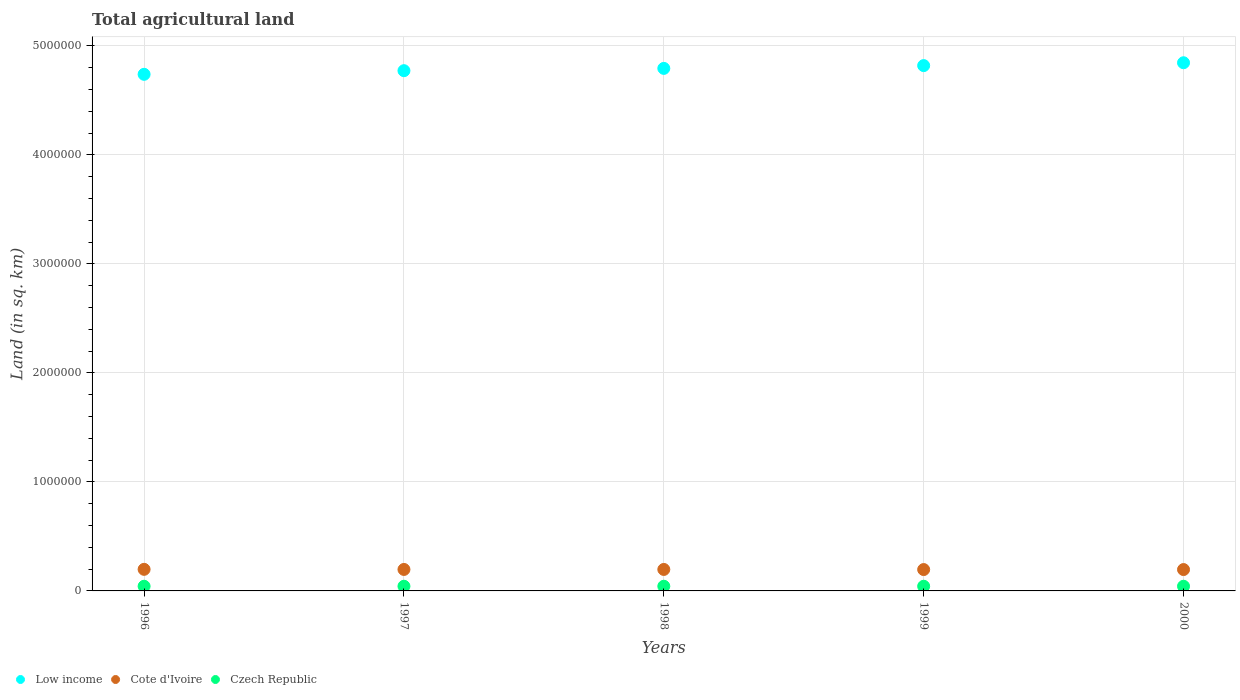How many different coloured dotlines are there?
Your answer should be compact. 3. What is the total agricultural land in Cote d'Ivoire in 1998?
Offer a very short reply. 1.97e+05. Across all years, what is the maximum total agricultural land in Cote d'Ivoire?
Keep it short and to the point. 1.98e+05. Across all years, what is the minimum total agricultural land in Low income?
Ensure brevity in your answer.  4.74e+06. In which year was the total agricultural land in Cote d'Ivoire maximum?
Your answer should be very brief. 1996. In which year was the total agricultural land in Low income minimum?
Your response must be concise. 1996. What is the total total agricultural land in Czech Republic in the graph?
Keep it short and to the point. 2.14e+05. What is the difference between the total agricultural land in Low income in 1999 and the total agricultural land in Czech Republic in 1996?
Your response must be concise. 4.78e+06. What is the average total agricultural land in Low income per year?
Provide a short and direct response. 4.79e+06. In the year 2000, what is the difference between the total agricultural land in Cote d'Ivoire and total agricultural land in Czech Republic?
Make the answer very short. 1.53e+05. In how many years, is the total agricultural land in Czech Republic greater than 4200000 sq.km?
Keep it short and to the point. 0. What is the ratio of the total agricultural land in Cote d'Ivoire in 1997 to that in 2000?
Offer a very short reply. 1.01. Is the difference between the total agricultural land in Cote d'Ivoire in 1998 and 1999 greater than the difference between the total agricultural land in Czech Republic in 1998 and 1999?
Give a very brief answer. Yes. What is the difference between the highest and the lowest total agricultural land in Czech Republic?
Your answer should be very brief. 40. Is the sum of the total agricultural land in Low income in 1999 and 2000 greater than the maximum total agricultural land in Czech Republic across all years?
Keep it short and to the point. Yes. Does the total agricultural land in Low income monotonically increase over the years?
Ensure brevity in your answer.  Yes. Is the total agricultural land in Czech Republic strictly greater than the total agricultural land in Low income over the years?
Make the answer very short. No. Is the total agricultural land in Low income strictly less than the total agricultural land in Cote d'Ivoire over the years?
Give a very brief answer. No. How many years are there in the graph?
Give a very brief answer. 5. What is the difference between two consecutive major ticks on the Y-axis?
Offer a very short reply. 1.00e+06. Does the graph contain grids?
Your answer should be compact. Yes. Where does the legend appear in the graph?
Keep it short and to the point. Bottom left. How many legend labels are there?
Offer a terse response. 3. What is the title of the graph?
Your answer should be compact. Total agricultural land. Does "Ecuador" appear as one of the legend labels in the graph?
Give a very brief answer. No. What is the label or title of the Y-axis?
Your answer should be very brief. Land (in sq. km). What is the Land (in sq. km) of Low income in 1996?
Offer a very short reply. 4.74e+06. What is the Land (in sq. km) of Cote d'Ivoire in 1996?
Make the answer very short. 1.98e+05. What is the Land (in sq. km) in Czech Republic in 1996?
Provide a short and direct response. 4.28e+04. What is the Land (in sq. km) of Low income in 1997?
Provide a short and direct response. 4.77e+06. What is the Land (in sq. km) in Cote d'Ivoire in 1997?
Provide a succinct answer. 1.97e+05. What is the Land (in sq. km) in Czech Republic in 1997?
Your answer should be compact. 4.28e+04. What is the Land (in sq. km) in Low income in 1998?
Provide a succinct answer. 4.79e+06. What is the Land (in sq. km) in Cote d'Ivoire in 1998?
Your response must be concise. 1.97e+05. What is the Land (in sq. km) of Czech Republic in 1998?
Offer a terse response. 4.28e+04. What is the Land (in sq. km) of Low income in 1999?
Your answer should be very brief. 4.82e+06. What is the Land (in sq. km) in Cote d'Ivoire in 1999?
Your answer should be very brief. 1.96e+05. What is the Land (in sq. km) of Czech Republic in 1999?
Provide a succinct answer. 4.28e+04. What is the Land (in sq. km) in Low income in 2000?
Provide a short and direct response. 4.85e+06. What is the Land (in sq. km) in Cote d'Ivoire in 2000?
Your response must be concise. 1.96e+05. What is the Land (in sq. km) of Czech Republic in 2000?
Provide a short and direct response. 4.28e+04. Across all years, what is the maximum Land (in sq. km) in Low income?
Make the answer very short. 4.85e+06. Across all years, what is the maximum Land (in sq. km) of Cote d'Ivoire?
Keep it short and to the point. 1.98e+05. Across all years, what is the maximum Land (in sq. km) of Czech Republic?
Provide a short and direct response. 4.28e+04. Across all years, what is the minimum Land (in sq. km) in Low income?
Give a very brief answer. 4.74e+06. Across all years, what is the minimum Land (in sq. km) in Cote d'Ivoire?
Ensure brevity in your answer.  1.96e+05. Across all years, what is the minimum Land (in sq. km) of Czech Republic?
Ensure brevity in your answer.  4.28e+04. What is the total Land (in sq. km) of Low income in the graph?
Make the answer very short. 2.40e+07. What is the total Land (in sq. km) in Cote d'Ivoire in the graph?
Keep it short and to the point. 9.84e+05. What is the total Land (in sq. km) of Czech Republic in the graph?
Offer a very short reply. 2.14e+05. What is the difference between the Land (in sq. km) in Low income in 1996 and that in 1997?
Ensure brevity in your answer.  -3.34e+04. What is the difference between the Land (in sq. km) in Low income in 1996 and that in 1998?
Make the answer very short. -5.44e+04. What is the difference between the Land (in sq. km) of Cote d'Ivoire in 1996 and that in 1998?
Give a very brief answer. 1000. What is the difference between the Land (in sq. km) in Czech Republic in 1996 and that in 1998?
Your answer should be very brief. -40. What is the difference between the Land (in sq. km) in Low income in 1996 and that in 1999?
Provide a succinct answer. -8.00e+04. What is the difference between the Land (in sq. km) in Low income in 1996 and that in 2000?
Your response must be concise. -1.06e+05. What is the difference between the Land (in sq. km) in Czech Republic in 1996 and that in 2000?
Provide a succinct answer. 0. What is the difference between the Land (in sq. km) in Low income in 1997 and that in 1998?
Provide a short and direct response. -2.10e+04. What is the difference between the Land (in sq. km) in Cote d'Ivoire in 1997 and that in 1998?
Your answer should be very brief. 0. What is the difference between the Land (in sq. km) in Czech Republic in 1997 and that in 1998?
Offer a terse response. -40. What is the difference between the Land (in sq. km) of Low income in 1997 and that in 1999?
Provide a short and direct response. -4.66e+04. What is the difference between the Land (in sq. km) of Cote d'Ivoire in 1997 and that in 1999?
Make the answer very short. 1000. What is the difference between the Land (in sq. km) in Czech Republic in 1997 and that in 1999?
Your response must be concise. -20. What is the difference between the Land (in sq. km) in Low income in 1997 and that in 2000?
Ensure brevity in your answer.  -7.28e+04. What is the difference between the Land (in sq. km) in Cote d'Ivoire in 1997 and that in 2000?
Ensure brevity in your answer.  1000. What is the difference between the Land (in sq. km) in Low income in 1998 and that in 1999?
Your answer should be very brief. -2.56e+04. What is the difference between the Land (in sq. km) in Low income in 1998 and that in 2000?
Offer a very short reply. -5.17e+04. What is the difference between the Land (in sq. km) in Low income in 1999 and that in 2000?
Your answer should be compact. -2.61e+04. What is the difference between the Land (in sq. km) of Cote d'Ivoire in 1999 and that in 2000?
Your answer should be very brief. 0. What is the difference between the Land (in sq. km) of Czech Republic in 1999 and that in 2000?
Offer a very short reply. 20. What is the difference between the Land (in sq. km) in Low income in 1996 and the Land (in sq. km) in Cote d'Ivoire in 1997?
Make the answer very short. 4.54e+06. What is the difference between the Land (in sq. km) of Low income in 1996 and the Land (in sq. km) of Czech Republic in 1997?
Provide a succinct answer. 4.70e+06. What is the difference between the Land (in sq. km) in Cote d'Ivoire in 1996 and the Land (in sq. km) in Czech Republic in 1997?
Your answer should be very brief. 1.55e+05. What is the difference between the Land (in sq. km) of Low income in 1996 and the Land (in sq. km) of Cote d'Ivoire in 1998?
Keep it short and to the point. 4.54e+06. What is the difference between the Land (in sq. km) in Low income in 1996 and the Land (in sq. km) in Czech Republic in 1998?
Provide a short and direct response. 4.70e+06. What is the difference between the Land (in sq. km) in Cote d'Ivoire in 1996 and the Land (in sq. km) in Czech Republic in 1998?
Offer a terse response. 1.55e+05. What is the difference between the Land (in sq. km) in Low income in 1996 and the Land (in sq. km) in Cote d'Ivoire in 1999?
Offer a terse response. 4.54e+06. What is the difference between the Land (in sq. km) of Low income in 1996 and the Land (in sq. km) of Czech Republic in 1999?
Provide a succinct answer. 4.70e+06. What is the difference between the Land (in sq. km) in Cote d'Ivoire in 1996 and the Land (in sq. km) in Czech Republic in 1999?
Give a very brief answer. 1.55e+05. What is the difference between the Land (in sq. km) in Low income in 1996 and the Land (in sq. km) in Cote d'Ivoire in 2000?
Offer a very short reply. 4.54e+06. What is the difference between the Land (in sq. km) in Low income in 1996 and the Land (in sq. km) in Czech Republic in 2000?
Provide a succinct answer. 4.70e+06. What is the difference between the Land (in sq. km) in Cote d'Ivoire in 1996 and the Land (in sq. km) in Czech Republic in 2000?
Give a very brief answer. 1.55e+05. What is the difference between the Land (in sq. km) of Low income in 1997 and the Land (in sq. km) of Cote d'Ivoire in 1998?
Your answer should be very brief. 4.58e+06. What is the difference between the Land (in sq. km) of Low income in 1997 and the Land (in sq. km) of Czech Republic in 1998?
Give a very brief answer. 4.73e+06. What is the difference between the Land (in sq. km) of Cote d'Ivoire in 1997 and the Land (in sq. km) of Czech Republic in 1998?
Make the answer very short. 1.54e+05. What is the difference between the Land (in sq. km) in Low income in 1997 and the Land (in sq. km) in Cote d'Ivoire in 1999?
Provide a short and direct response. 4.58e+06. What is the difference between the Land (in sq. km) in Low income in 1997 and the Land (in sq. km) in Czech Republic in 1999?
Keep it short and to the point. 4.73e+06. What is the difference between the Land (in sq. km) of Cote d'Ivoire in 1997 and the Land (in sq. km) of Czech Republic in 1999?
Your response must be concise. 1.54e+05. What is the difference between the Land (in sq. km) of Low income in 1997 and the Land (in sq. km) of Cote d'Ivoire in 2000?
Provide a succinct answer. 4.58e+06. What is the difference between the Land (in sq. km) in Low income in 1997 and the Land (in sq. km) in Czech Republic in 2000?
Your answer should be very brief. 4.73e+06. What is the difference between the Land (in sq. km) in Cote d'Ivoire in 1997 and the Land (in sq. km) in Czech Republic in 2000?
Give a very brief answer. 1.54e+05. What is the difference between the Land (in sq. km) of Low income in 1998 and the Land (in sq. km) of Cote d'Ivoire in 1999?
Ensure brevity in your answer.  4.60e+06. What is the difference between the Land (in sq. km) of Low income in 1998 and the Land (in sq. km) of Czech Republic in 1999?
Your answer should be compact. 4.75e+06. What is the difference between the Land (in sq. km) of Cote d'Ivoire in 1998 and the Land (in sq. km) of Czech Republic in 1999?
Keep it short and to the point. 1.54e+05. What is the difference between the Land (in sq. km) of Low income in 1998 and the Land (in sq. km) of Cote d'Ivoire in 2000?
Provide a short and direct response. 4.60e+06. What is the difference between the Land (in sq. km) in Low income in 1998 and the Land (in sq. km) in Czech Republic in 2000?
Make the answer very short. 4.75e+06. What is the difference between the Land (in sq. km) in Cote d'Ivoire in 1998 and the Land (in sq. km) in Czech Republic in 2000?
Keep it short and to the point. 1.54e+05. What is the difference between the Land (in sq. km) of Low income in 1999 and the Land (in sq. km) of Cote d'Ivoire in 2000?
Keep it short and to the point. 4.62e+06. What is the difference between the Land (in sq. km) of Low income in 1999 and the Land (in sq. km) of Czech Republic in 2000?
Offer a terse response. 4.78e+06. What is the difference between the Land (in sq. km) in Cote d'Ivoire in 1999 and the Land (in sq. km) in Czech Republic in 2000?
Your answer should be very brief. 1.53e+05. What is the average Land (in sq. km) of Low income per year?
Make the answer very short. 4.79e+06. What is the average Land (in sq. km) in Cote d'Ivoire per year?
Give a very brief answer. 1.97e+05. What is the average Land (in sq. km) in Czech Republic per year?
Offer a terse response. 4.28e+04. In the year 1996, what is the difference between the Land (in sq. km) of Low income and Land (in sq. km) of Cote d'Ivoire?
Your answer should be very brief. 4.54e+06. In the year 1996, what is the difference between the Land (in sq. km) of Low income and Land (in sq. km) of Czech Republic?
Your answer should be very brief. 4.70e+06. In the year 1996, what is the difference between the Land (in sq. km) in Cote d'Ivoire and Land (in sq. km) in Czech Republic?
Your response must be concise. 1.55e+05. In the year 1997, what is the difference between the Land (in sq. km) in Low income and Land (in sq. km) in Cote d'Ivoire?
Ensure brevity in your answer.  4.58e+06. In the year 1997, what is the difference between the Land (in sq. km) of Low income and Land (in sq. km) of Czech Republic?
Your answer should be very brief. 4.73e+06. In the year 1997, what is the difference between the Land (in sq. km) in Cote d'Ivoire and Land (in sq. km) in Czech Republic?
Offer a very short reply. 1.54e+05. In the year 1998, what is the difference between the Land (in sq. km) of Low income and Land (in sq. km) of Cote d'Ivoire?
Your answer should be very brief. 4.60e+06. In the year 1998, what is the difference between the Land (in sq. km) of Low income and Land (in sq. km) of Czech Republic?
Give a very brief answer. 4.75e+06. In the year 1998, what is the difference between the Land (in sq. km) of Cote d'Ivoire and Land (in sq. km) of Czech Republic?
Ensure brevity in your answer.  1.54e+05. In the year 1999, what is the difference between the Land (in sq. km) of Low income and Land (in sq. km) of Cote d'Ivoire?
Make the answer very short. 4.62e+06. In the year 1999, what is the difference between the Land (in sq. km) of Low income and Land (in sq. km) of Czech Republic?
Your answer should be compact. 4.78e+06. In the year 1999, what is the difference between the Land (in sq. km) in Cote d'Ivoire and Land (in sq. km) in Czech Republic?
Offer a terse response. 1.53e+05. In the year 2000, what is the difference between the Land (in sq. km) in Low income and Land (in sq. km) in Cote d'Ivoire?
Ensure brevity in your answer.  4.65e+06. In the year 2000, what is the difference between the Land (in sq. km) of Low income and Land (in sq. km) of Czech Republic?
Keep it short and to the point. 4.80e+06. In the year 2000, what is the difference between the Land (in sq. km) of Cote d'Ivoire and Land (in sq. km) of Czech Republic?
Your answer should be compact. 1.53e+05. What is the ratio of the Land (in sq. km) of Low income in 1996 to that in 1997?
Offer a very short reply. 0.99. What is the ratio of the Land (in sq. km) of Cote d'Ivoire in 1996 to that in 1997?
Ensure brevity in your answer.  1.01. What is the ratio of the Land (in sq. km) of Czech Republic in 1996 to that in 1997?
Provide a succinct answer. 1. What is the ratio of the Land (in sq. km) in Low income in 1996 to that in 1998?
Ensure brevity in your answer.  0.99. What is the ratio of the Land (in sq. km) of Czech Republic in 1996 to that in 1998?
Give a very brief answer. 1. What is the ratio of the Land (in sq. km) of Low income in 1996 to that in 1999?
Provide a short and direct response. 0.98. What is the ratio of the Land (in sq. km) in Cote d'Ivoire in 1996 to that in 1999?
Your answer should be very brief. 1.01. What is the ratio of the Land (in sq. km) of Czech Republic in 1996 to that in 1999?
Make the answer very short. 1. What is the ratio of the Land (in sq. km) in Low income in 1996 to that in 2000?
Your answer should be compact. 0.98. What is the ratio of the Land (in sq. km) in Cote d'Ivoire in 1996 to that in 2000?
Your answer should be very brief. 1.01. What is the ratio of the Land (in sq. km) in Czech Republic in 1996 to that in 2000?
Provide a succinct answer. 1. What is the ratio of the Land (in sq. km) in Low income in 1997 to that in 1999?
Offer a terse response. 0.99. What is the ratio of the Land (in sq. km) of Cote d'Ivoire in 1997 to that in 1999?
Offer a very short reply. 1.01. What is the ratio of the Land (in sq. km) of Czech Republic in 1997 to that in 1999?
Make the answer very short. 1. What is the ratio of the Land (in sq. km) in Czech Republic in 1997 to that in 2000?
Offer a very short reply. 1. What is the ratio of the Land (in sq. km) of Low income in 1998 to that in 1999?
Give a very brief answer. 0.99. What is the ratio of the Land (in sq. km) in Cote d'Ivoire in 1998 to that in 1999?
Your answer should be very brief. 1.01. What is the ratio of the Land (in sq. km) in Czech Republic in 1998 to that in 1999?
Provide a succinct answer. 1. What is the ratio of the Land (in sq. km) of Low income in 1998 to that in 2000?
Your answer should be compact. 0.99. What is the ratio of the Land (in sq. km) of Low income in 1999 to that in 2000?
Offer a terse response. 0.99. What is the ratio of the Land (in sq. km) of Czech Republic in 1999 to that in 2000?
Keep it short and to the point. 1. What is the difference between the highest and the second highest Land (in sq. km) of Low income?
Give a very brief answer. 2.61e+04. What is the difference between the highest and the second highest Land (in sq. km) of Czech Republic?
Provide a succinct answer. 20. What is the difference between the highest and the lowest Land (in sq. km) of Low income?
Offer a very short reply. 1.06e+05. 